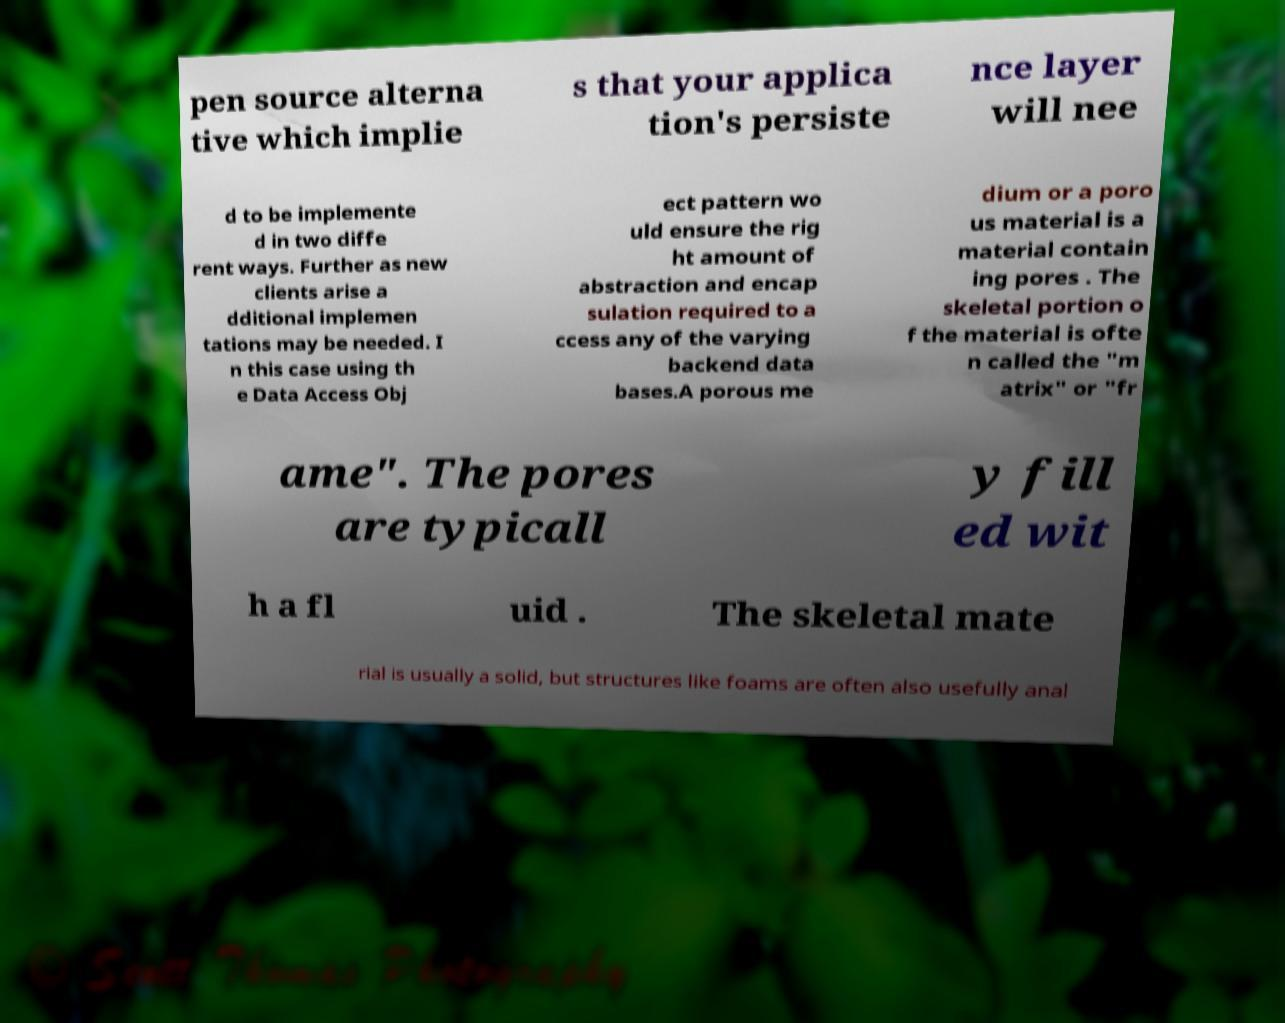Can you accurately transcribe the text from the provided image for me? pen source alterna tive which implie s that your applica tion's persiste nce layer will nee d to be implemente d in two diffe rent ways. Further as new clients arise a dditional implemen tations may be needed. I n this case using th e Data Access Obj ect pattern wo uld ensure the rig ht amount of abstraction and encap sulation required to a ccess any of the varying backend data bases.A porous me dium or a poro us material is a material contain ing pores . The skeletal portion o f the material is ofte n called the "m atrix" or "fr ame". The pores are typicall y fill ed wit h a fl uid . The skeletal mate rial is usually a solid, but structures like foams are often also usefully anal 